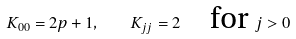Convert formula to latex. <formula><loc_0><loc_0><loc_500><loc_500>K _ { 0 0 } = 2 p + 1 , \quad K _ { j j } = 2 \quad \text {for } j > 0</formula> 